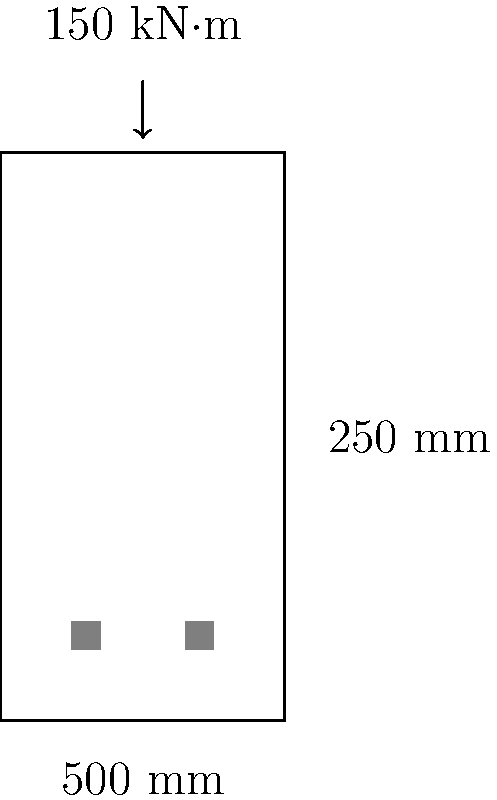Design a reinforced concrete beam cross-section for a simply supported beam with a span of 6 meters. The beam is subjected to a maximum bending moment of 150 kN·m. The cross-section dimensions are 250 mm wide and 500 mm deep. Assume concrete strength $f'_c = 30$ MPa and steel yield strength $f_y = 420$ MPa. Determine the required area of tensile reinforcement for the beam. To design the reinforced concrete beam cross-section, we'll follow these steps:

1. Calculate the effective depth (d):
   Assuming 40 mm cover and 20 mm bar diameter:
   $d = 500 - 40 - 20/2 = 450$ mm

2. Determine the balanced steel ratio ($\rho_b$):
   $\rho_b = 0.85\beta_1\frac{f'_c}{f_y}\frac{600}{600+f_y}$
   Where $\beta_1 = 0.85$ for $f'_c \leq 30$ MPa
   $\rho_b = 0.85 \times 0.85 \times \frac{30}{420} \times \frac{600}{600+420} = 0.0286$

3. Calculate the maximum steel ratio ($\rho_{max}$):
   $\rho_{max} = 0.75\rho_b = 0.75 \times 0.0286 = 0.02145$

4. Compute the required steel ratio ($\rho$):
   $\rho = \frac{0.85f'_c}{f_y}[1-\sqrt{1-\frac{2M_u}{\phi 0.85f'_c bd^2}}]$
   Where $\phi = 0.9$ for tension-controlled sections
   $\rho = \frac{0.85 \times 30}{420}[1-\sqrt{1-\frac{2 \times 150 \times 10^6}{0.9 \times 0.85 \times 30 \times 250 \times 450^2}}] = 0.0118$

5. Check if $\rho < \rho_{max}$:
   $0.0118 < 0.02145$, so the section is tension-controlled

6. Calculate the required area of steel ($A_s$):
   $A_s = \rho bd = 0.0118 \times 250 \times 450 = 1327.5$ mm²

Therefore, the required area of tensile reinforcement is 1327.5 mm².
Answer: 1327.5 mm² 